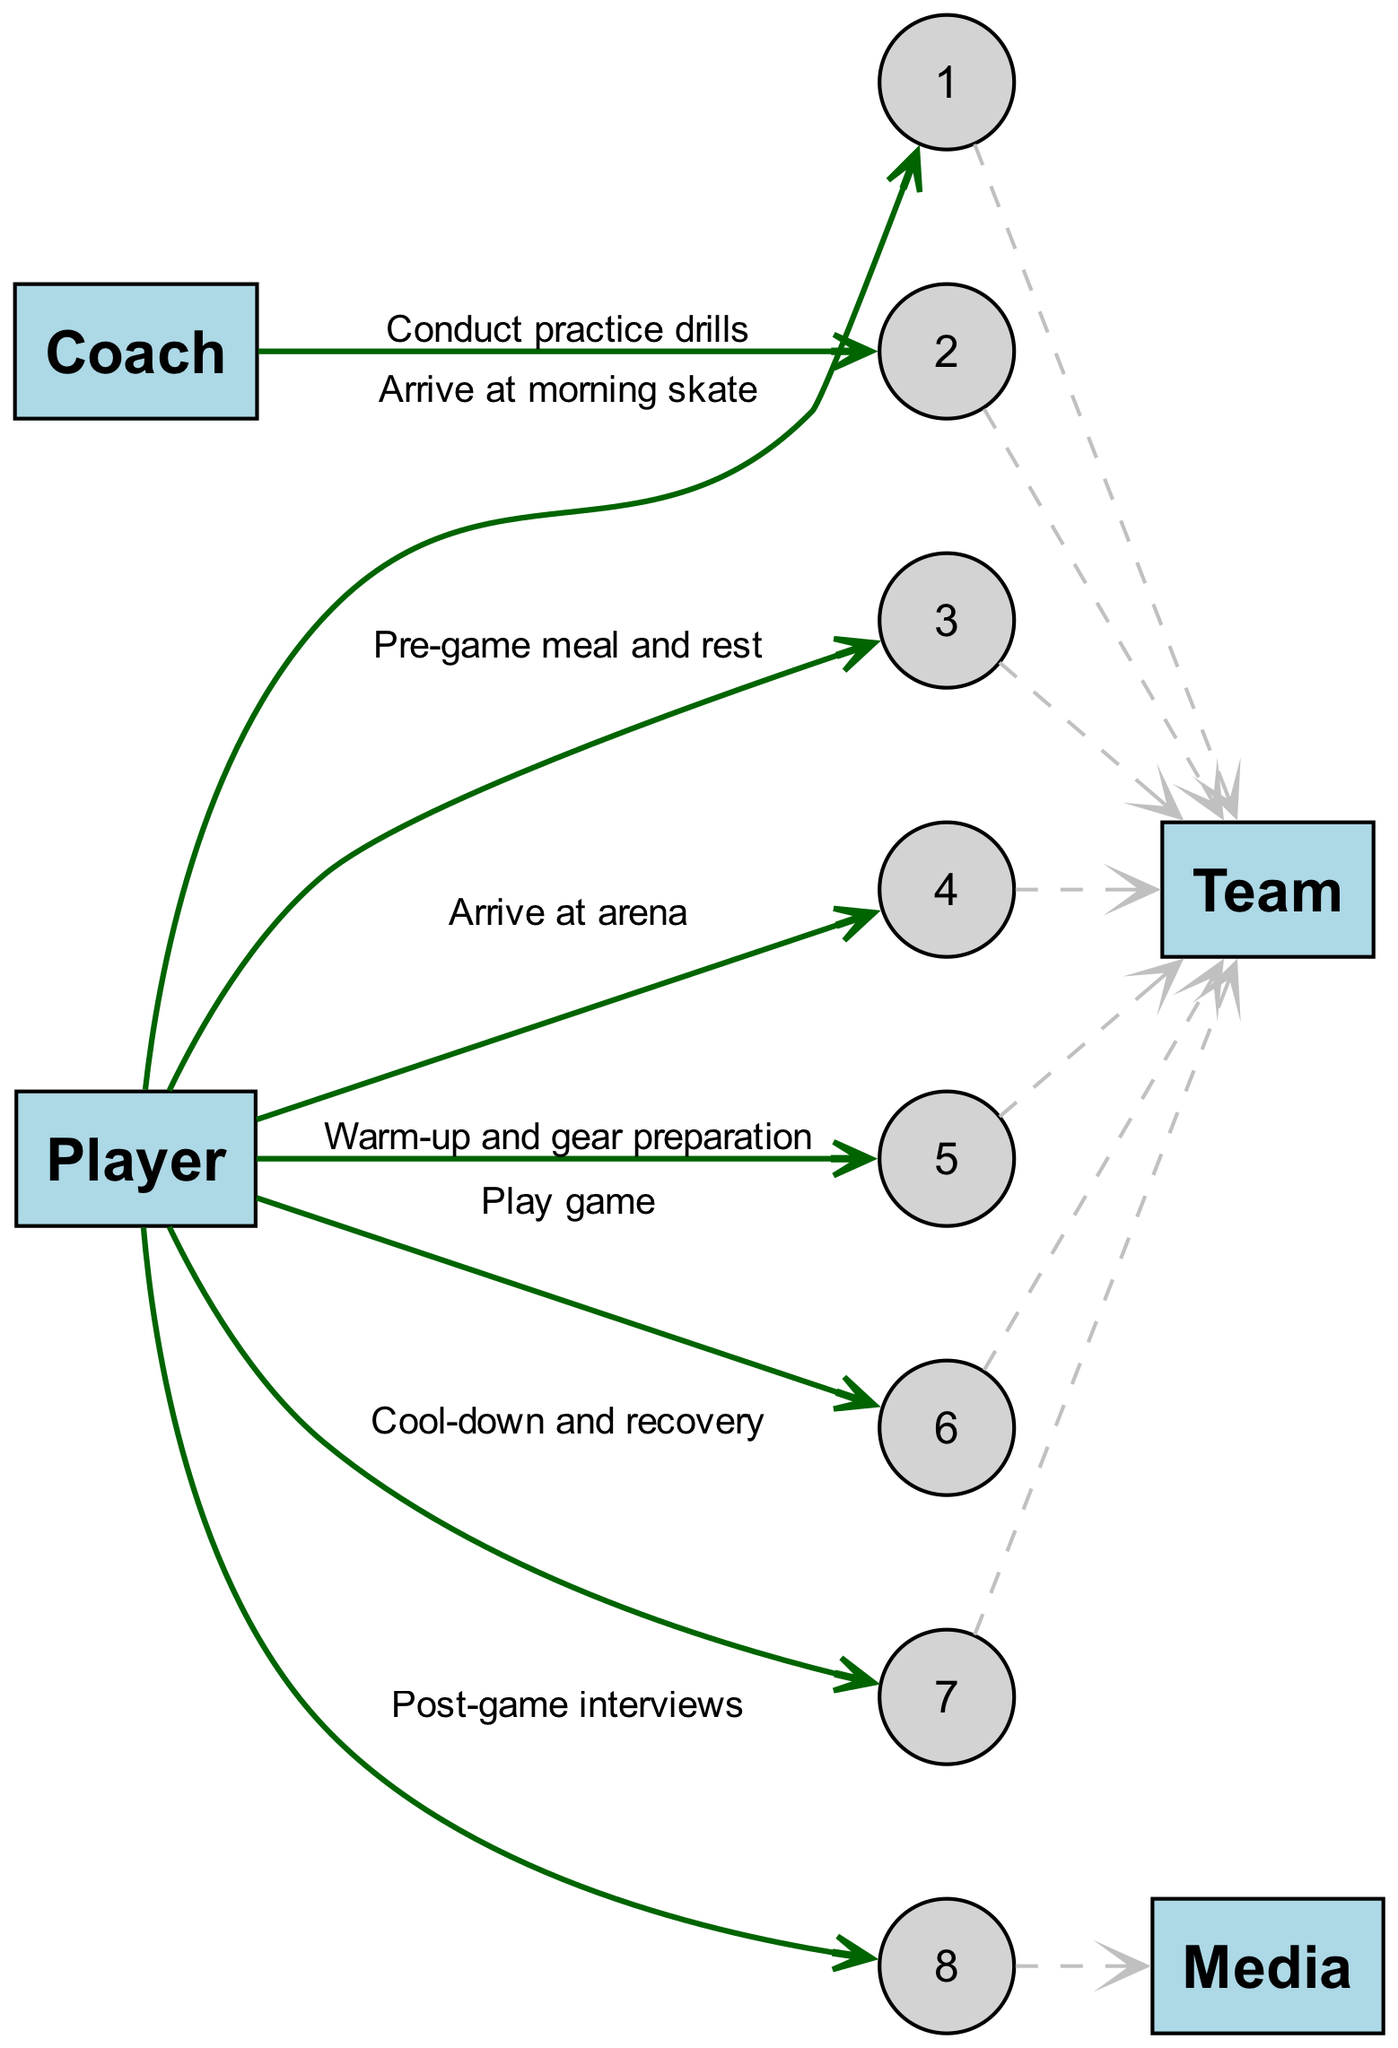What is the first action of the Player in the sequence? The first action of the Player is to arrive at morning skate, which is the initial step shown in the diagram.
Answer: Arrive at morning skate How many actors are involved in this sequence? The diagram lists four distinct actors: Player, Coach, Team, and Media. Thus, the total count is four.
Answer: 4 What action follows 'Conduct practice drills'? After 'Conduct practice drills', the next action is 'Pre-game meal and rest', indicating the order of events in the sequence.
Answer: Pre-game meal and rest Which actor is responsible for conducting practice drills? The Coach is identified as the actor responsible for conducting practice drills according to the diagram's events.
Answer: Coach What is the last action of the Player during the game day sequence? The final action for the Player specified in the sequence is 'Post-game interviews', marking the end of the day's activities represented in the diagram.
Answer: Post-game interviews How many actions does the Player perform in total? The Player is shown to perform a total of five distinct actions throughout the sequence, highlighting their responsibilities during the game day.
Answer: 5 Which action immediately precedes the 'Play game' activity? The action immediately preceding 'Play game' is 'Warm-up and gear preparation', indicating it as a preparatory step before competing.
Answer: Warm-up and gear preparation What type of relationship connects 'Player' to 'Media'? The relationship connecting 'Player' to 'Media' is represented by the action of 'Post-game interviews', establishing a direct communication interaction between them.
Answer: Post-game interviews What is the sequence order of the Player's actions? The sequence order for the Player's actions is as follows: Arrive at morning skate, Pre-game meal and rest, Arrive at arena, Warm-up and gear preparation, Play game, Cool-down and recovery, Post-game interviews.
Answer: Arrive at morning skate, Pre-game meal and rest, Arrive at arena, Warm-up and gear preparation, Play game, Cool-down and recovery, Post-game interviews 